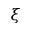Convert formula to latex. <formula><loc_0><loc_0><loc_500><loc_500>\xi</formula> 